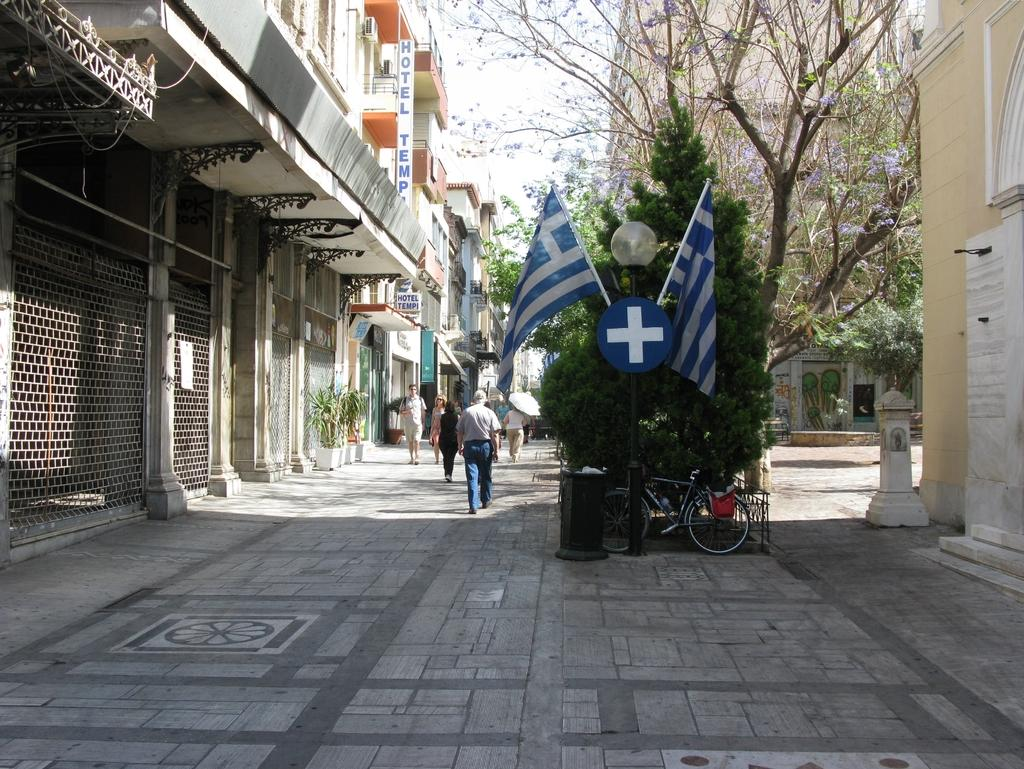What are the people in the image doing? The people in the image are walking in a path. What can be seen in the background of the image? There are buildings and trees visible in the image. What decorative elements are present in the image? There are flags in the image. What verse is being recited by the trees in the image? There are no verses being recited by the trees in the image, as trees do not have the ability to recite verses. 